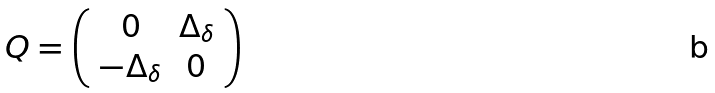Convert formula to latex. <formula><loc_0><loc_0><loc_500><loc_500>Q = \left ( \begin{array} { c c } 0 & \Delta _ { \delta } \\ - \Delta _ { \delta } & 0 \end{array} \right )</formula> 